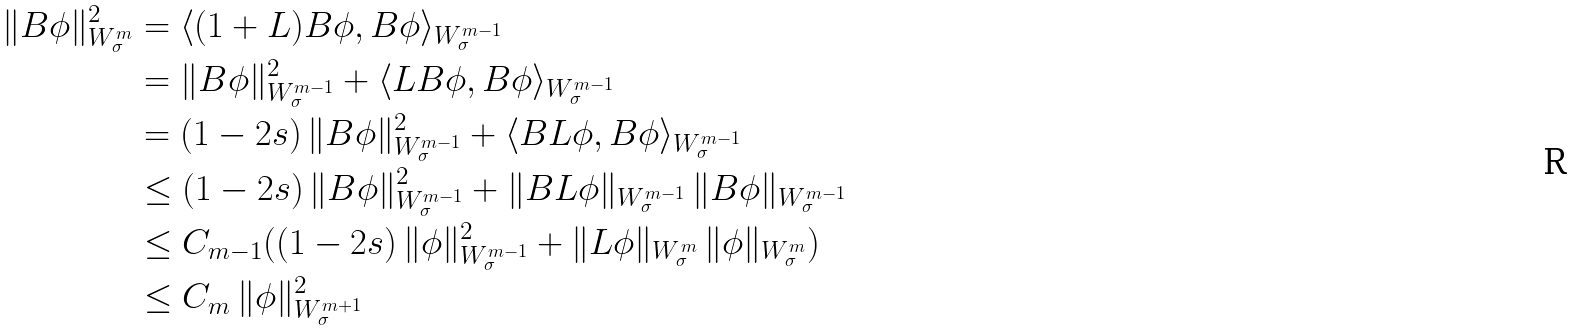<formula> <loc_0><loc_0><loc_500><loc_500>\| B \phi \| _ { W _ { \sigma } ^ { m } } ^ { 2 } & = \langle ( 1 + L ) B \phi , B \phi \rangle _ { W _ { \sigma } ^ { m - 1 } } \\ & = \| B \phi \| _ { W _ { \sigma } ^ { m - 1 } } ^ { 2 } + \langle L B \phi , B \phi \rangle _ { W _ { \sigma } ^ { m - 1 } } \\ & = ( 1 - 2 s ) \, \| B \phi \| _ { W _ { \sigma } ^ { m - 1 } } ^ { 2 } + \langle B L \phi , B \phi \rangle _ { W _ { \sigma } ^ { m - 1 } } \\ & \leq ( 1 - 2 s ) \, \| B \phi \| _ { W _ { \sigma } ^ { m - 1 } } ^ { 2 } + \| B L \phi \| _ { W _ { \sigma } ^ { m - 1 } } \, \| B \phi \| _ { W _ { \sigma } ^ { m - 1 } } \\ & \leq C _ { m - 1 } ( ( 1 - 2 s ) \, \| \phi \| _ { W _ { \sigma } ^ { m - 1 } } ^ { 2 } + \| L \phi \| _ { W _ { \sigma } ^ { m } } \, \| \phi \| _ { W _ { \sigma } ^ { m } } ) \\ & \leq C _ { m } \, \| \phi \| _ { W _ { \sigma } ^ { m + 1 } } ^ { 2 }</formula> 